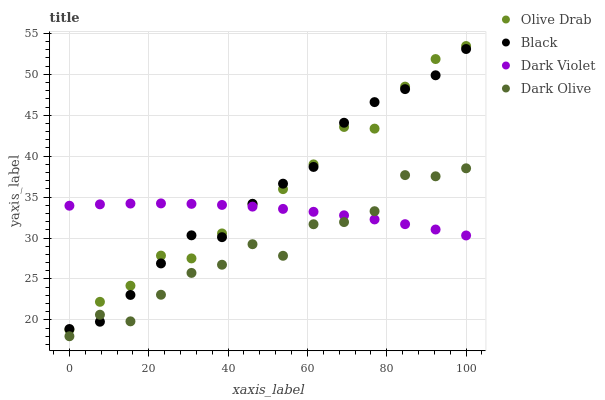Does Dark Olive have the minimum area under the curve?
Answer yes or no. Yes. Does Olive Drab have the maximum area under the curve?
Answer yes or no. Yes. Does Black have the minimum area under the curve?
Answer yes or no. No. Does Black have the maximum area under the curve?
Answer yes or no. No. Is Dark Violet the smoothest?
Answer yes or no. Yes. Is Dark Olive the roughest?
Answer yes or no. Yes. Is Black the smoothest?
Answer yes or no. No. Is Black the roughest?
Answer yes or no. No. Does Dark Olive have the lowest value?
Answer yes or no. Yes. Does Black have the lowest value?
Answer yes or no. No. Does Olive Drab have the highest value?
Answer yes or no. Yes. Does Black have the highest value?
Answer yes or no. No. Is Dark Olive less than Olive Drab?
Answer yes or no. Yes. Is Olive Drab greater than Dark Olive?
Answer yes or no. Yes. Does Olive Drab intersect Dark Violet?
Answer yes or no. Yes. Is Olive Drab less than Dark Violet?
Answer yes or no. No. Is Olive Drab greater than Dark Violet?
Answer yes or no. No. Does Dark Olive intersect Olive Drab?
Answer yes or no. No. 